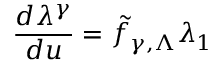Convert formula to latex. <formula><loc_0><loc_0><loc_500><loc_500>\frac { d \lambda ^ { \gamma } } { d u } = { \tilde { f } } _ { \gamma , \Lambda } \lambda _ { 1 }</formula> 